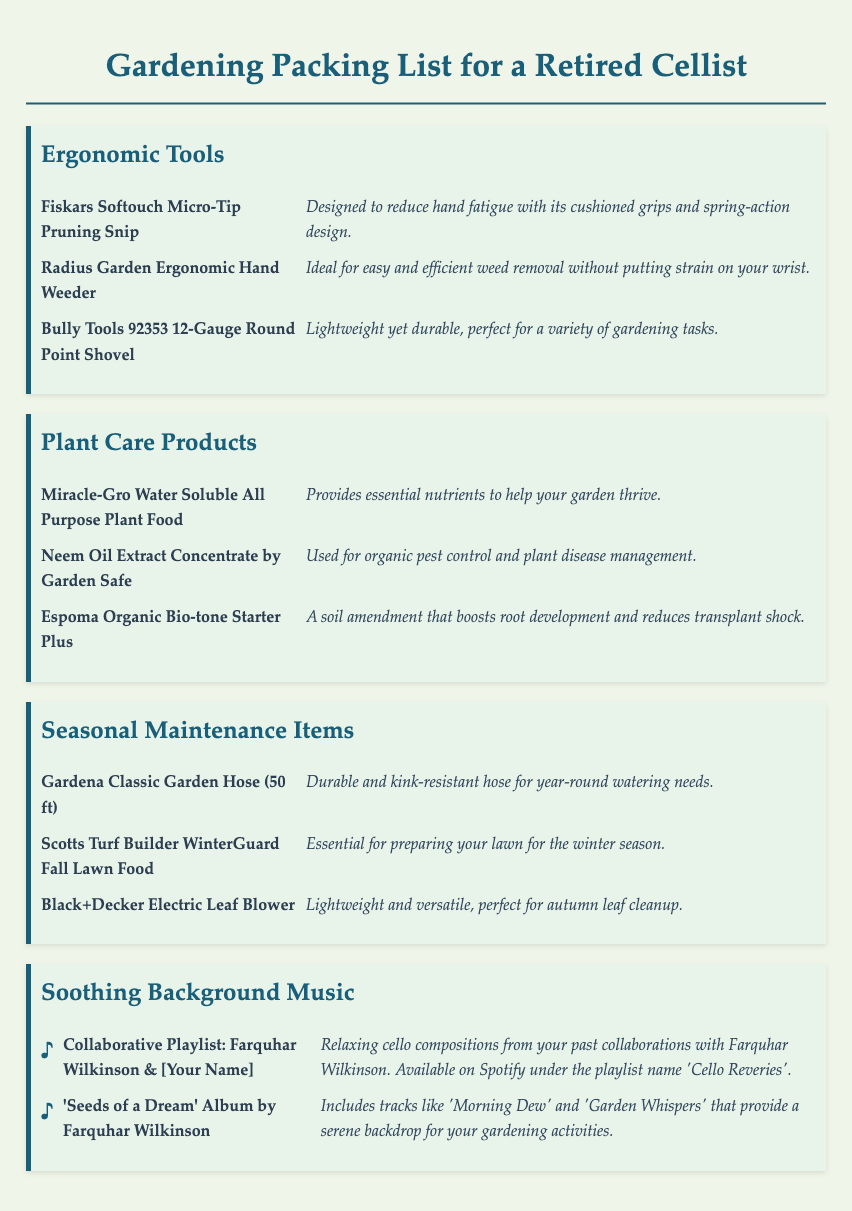what is the title of the document? The title of the document is mentioned in the `<title>` tag in the HTML, which is "Gardening Packing List for a Retired Cellist".
Answer: Gardening Packing List for a Retired Cellist how many ergonomic tools are listed? The document contains a category titled "Ergonomic Tools" with three items listed under it.
Answer: 3 what is the purpose of Neem Oil Extract Concentrate? The document provides a description of Neem Oil Extract Concentrate under "Plant Care Products" that states its use.
Answer: Organic pest control and plant disease management which electric tool is mentioned for autumn leaf cleanup? The document specifically mentions the Black+Decker Electric Leaf Blower under "Seasonal Maintenance Items".
Answer: Black+Decker Electric Leaf Blower what type of music is suggested for gardening? The document describes musical items in the "Soothing Background Music" category which are designed for a relaxing atmosphere while gardening.
Answer: Relaxing cello compositions what item provides essential nutrients for plants? This is found in the "Plant Care Products" section where Miracle-Gro Water Soluble All Purpose Plant Food is mentioned.
Answer: Miracle-Gro Water Soluble All Purpose Plant Food what is the length of the mentioned garden hose? The document specifies that the Gardena Classic Garden Hose is 50 ft long in the "Seasonal Maintenance Items" section.
Answer: 50 ft name one track from the "Seeds of a Dream" album. The document lists tracks like 'Morning Dew' and 'Garden Whispers' under the soothing music section.
Answer: Morning Dew 